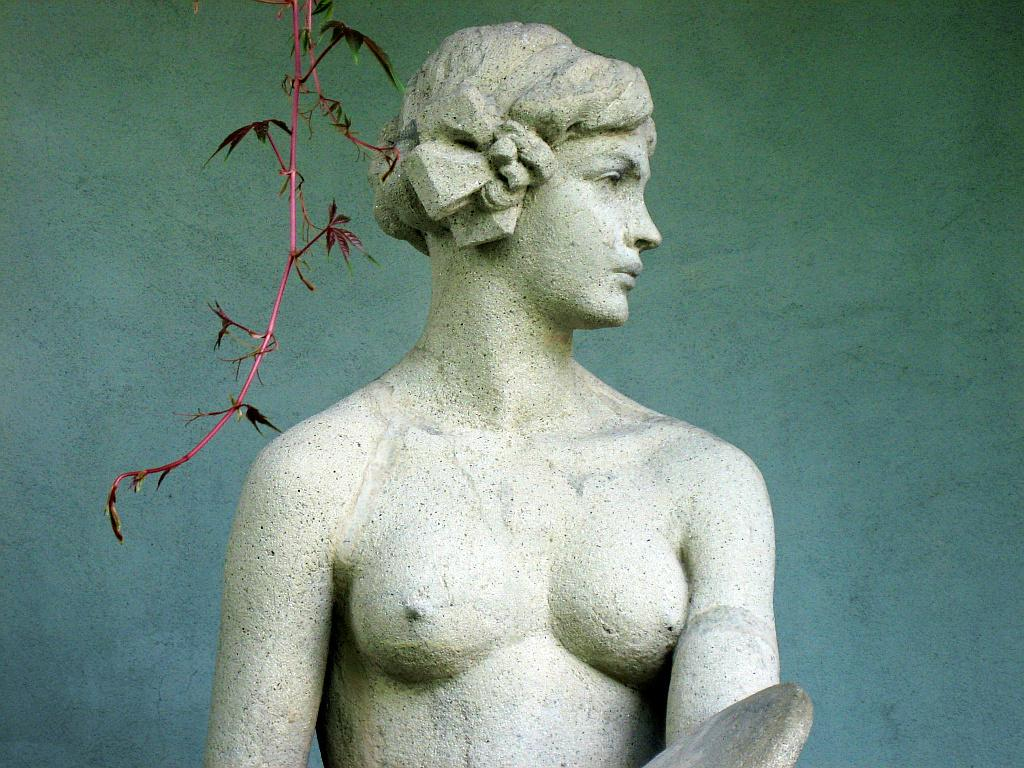What is the main subject of the image? There is a sculpture in the center of the image. Can you describe any specific features of the sculpture? Yes, there is a stem at the top of the sculpture. What can be seen in the background of the image? There is a wall in the background of the image. How many eggs are visible on the sculpture in the image? There are no eggs present on the sculpture in the image. Is the sculpture wearing a veil in the image? There is no indication of a veil or any clothing on the sculpture in the image. 